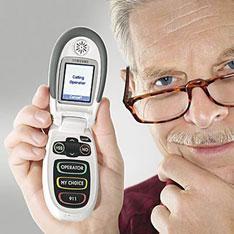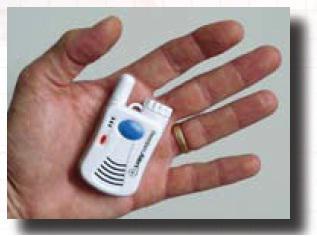The first image is the image on the left, the second image is the image on the right. For the images shown, is this caption "In one image there is a red flip phone and in the other image there is a hand holding a grey and black phone." true? Answer yes or no. No. The first image is the image on the left, the second image is the image on the right. For the images displayed, is the sentence "An image shows a gray-haired man with one hand on his chin and a phone on the left." factually correct? Answer yes or no. Yes. 